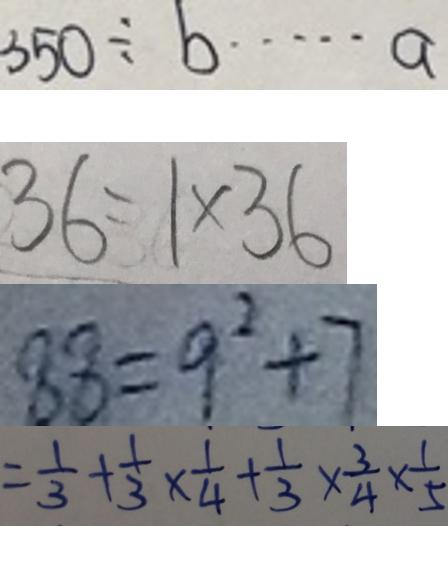Convert formula to latex. <formula><loc_0><loc_0><loc_500><loc_500>3 5 0 \div b \cdots a 
 3 6 = 1 \times 3 6 
 8 8 = 9 ^ { 2 } + 7 
 = \frac { 1 } { 3 } + \frac { 1 } { 3 } \times \frac { 1 } { 4 } + \frac { 1 } { 3 } \times \frac { 3 } { 4 } \times \frac { 1 } { 5 }</formula> 